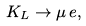Convert formula to latex. <formula><loc_0><loc_0><loc_500><loc_500>K _ { L } \rightarrow \mu \, e ,</formula> 